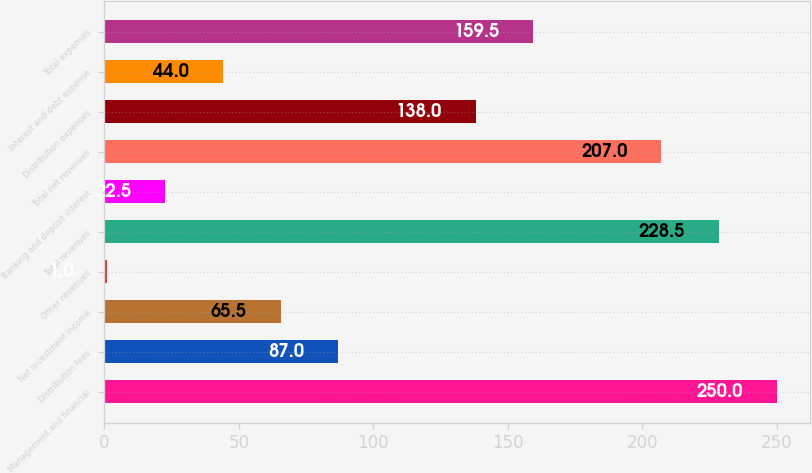<chart> <loc_0><loc_0><loc_500><loc_500><bar_chart><fcel>Management and financial<fcel>Distribution fees<fcel>Net investment income<fcel>Other revenues<fcel>Total revenues<fcel>Banking and deposit interest<fcel>Total net revenues<fcel>Distribution expenses<fcel>Interest and debt expense<fcel>Total expenses<nl><fcel>250<fcel>87<fcel>65.5<fcel>1<fcel>228.5<fcel>22.5<fcel>207<fcel>138<fcel>44<fcel>159.5<nl></chart> 